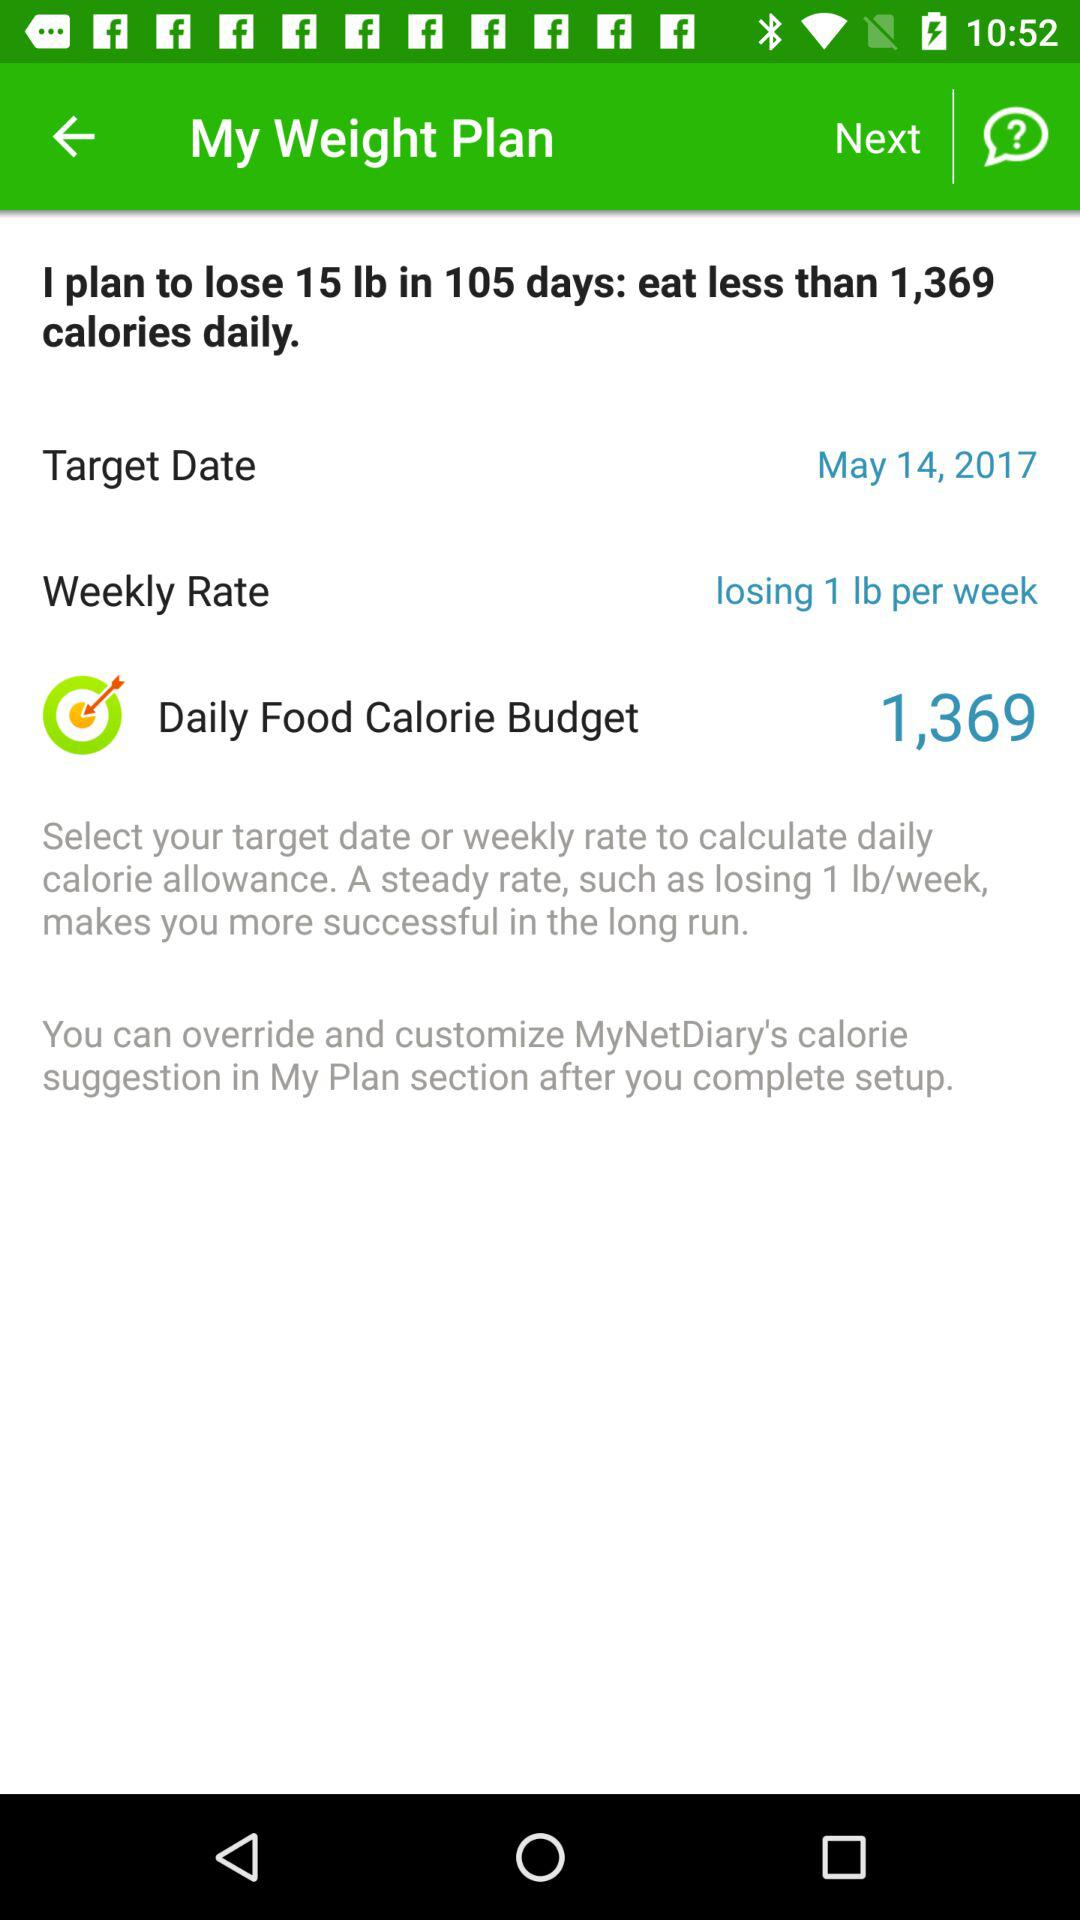How many pounds do I plan to lose?
Answer the question using a single word or phrase. 15 